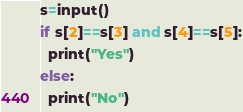<code> <loc_0><loc_0><loc_500><loc_500><_Python_>s=input()
if s[2]==s[3] and s[4]==s[5]:
  print("Yes")
else:
  print("No")</code> 